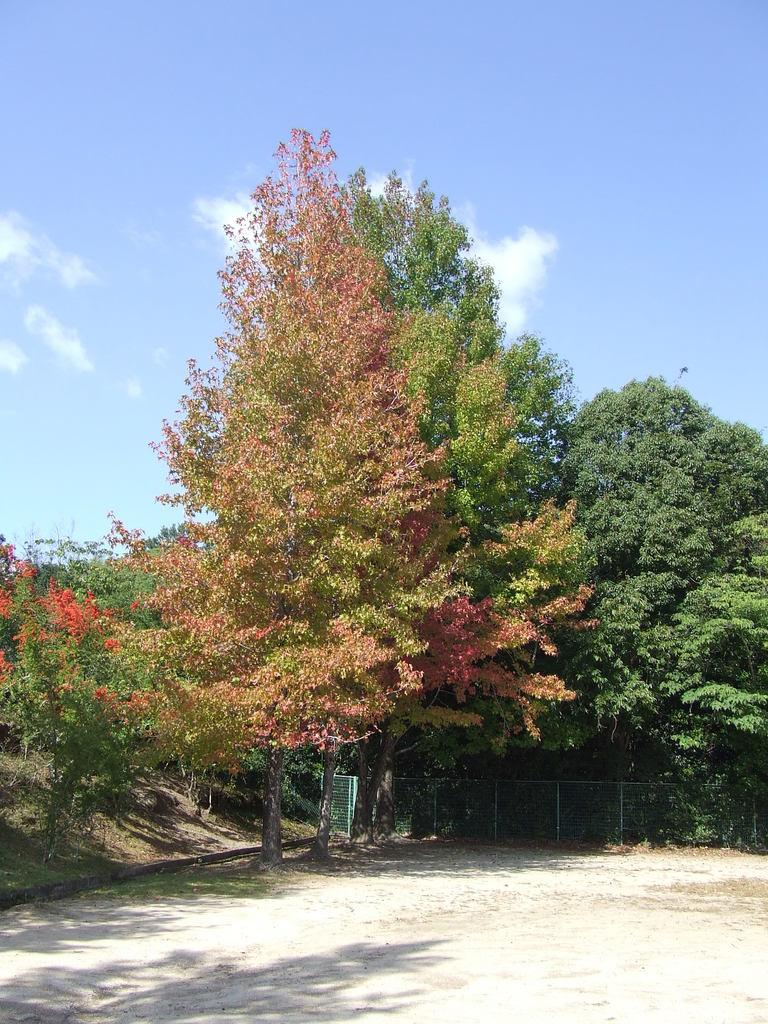What is visible at the bottom of the image? The ground is visible in the image. What type of structure can be seen in the image? There is a fence in the image. What type of vegetation is present in the image? Trees are present in the image. What is visible in the distance in the image? The sky is visible in the background of the image. What type of dinosaurs can be seen roaming in the image? There are no dinosaurs present in the image; it features a fence, trees, and the sky. What is the best way to travel to the nation depicted in the image? The image does not depict a specific nation, so it is not possible to determine the best way to travel there. 